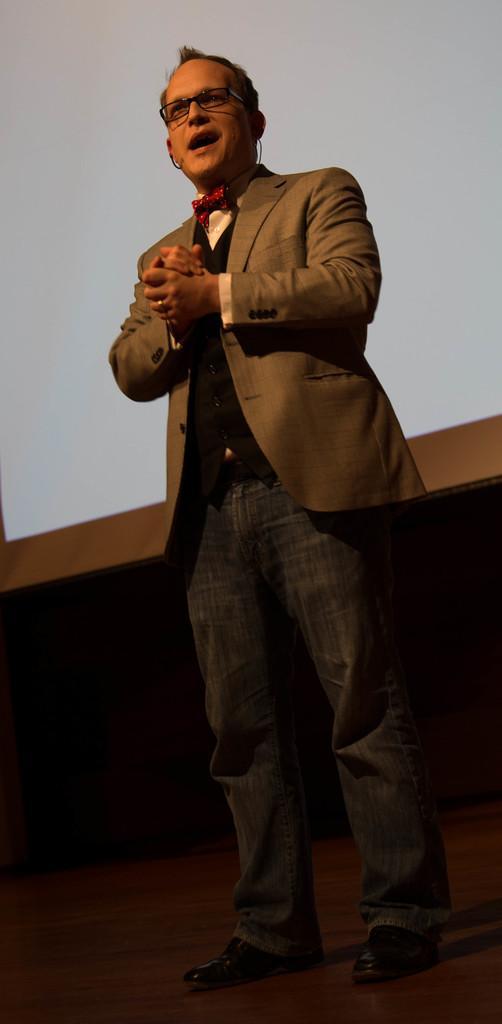How would you summarize this image in a sentence or two? In this image in the front there is a man standing and speaking. In the background there are objects which are white, brown and black in colour. 